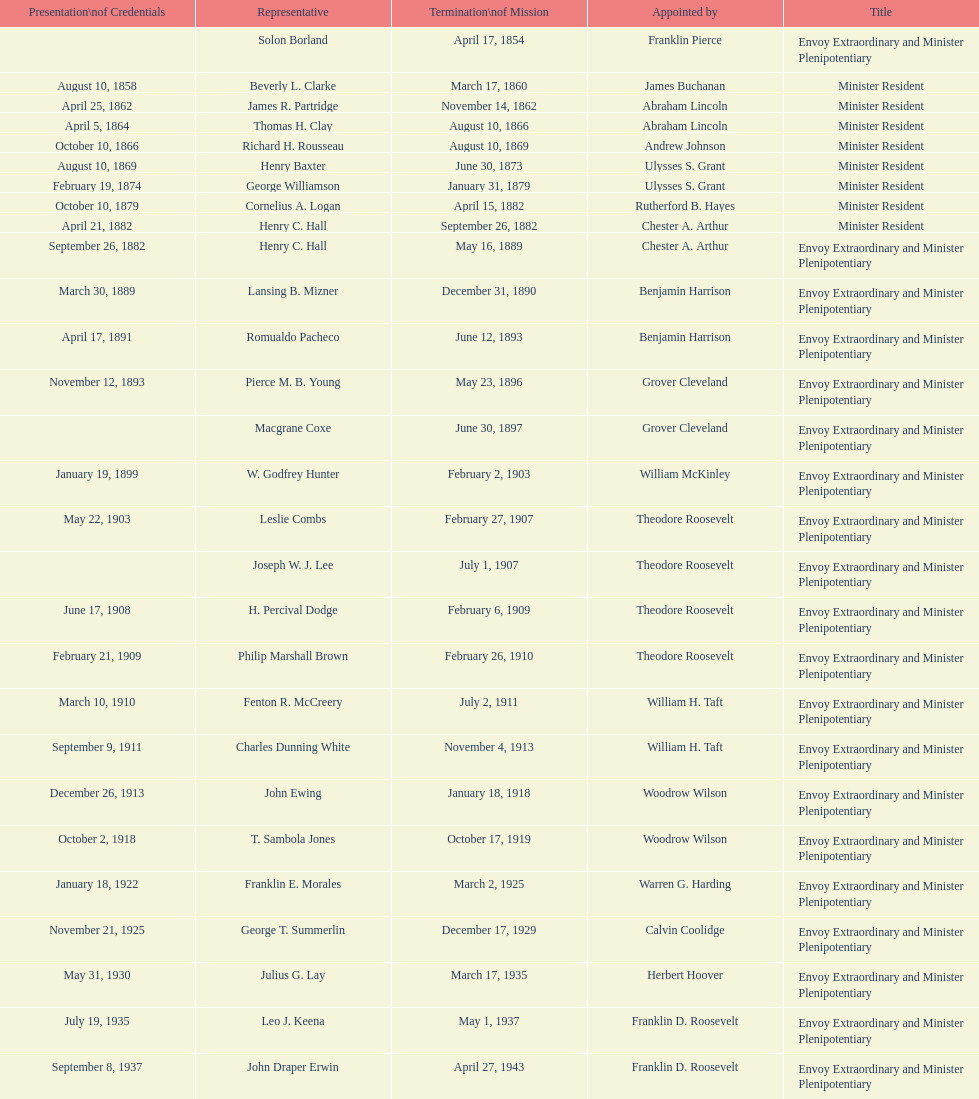Which envoy was the first appointed by woodrow wilson? John Ewing. 